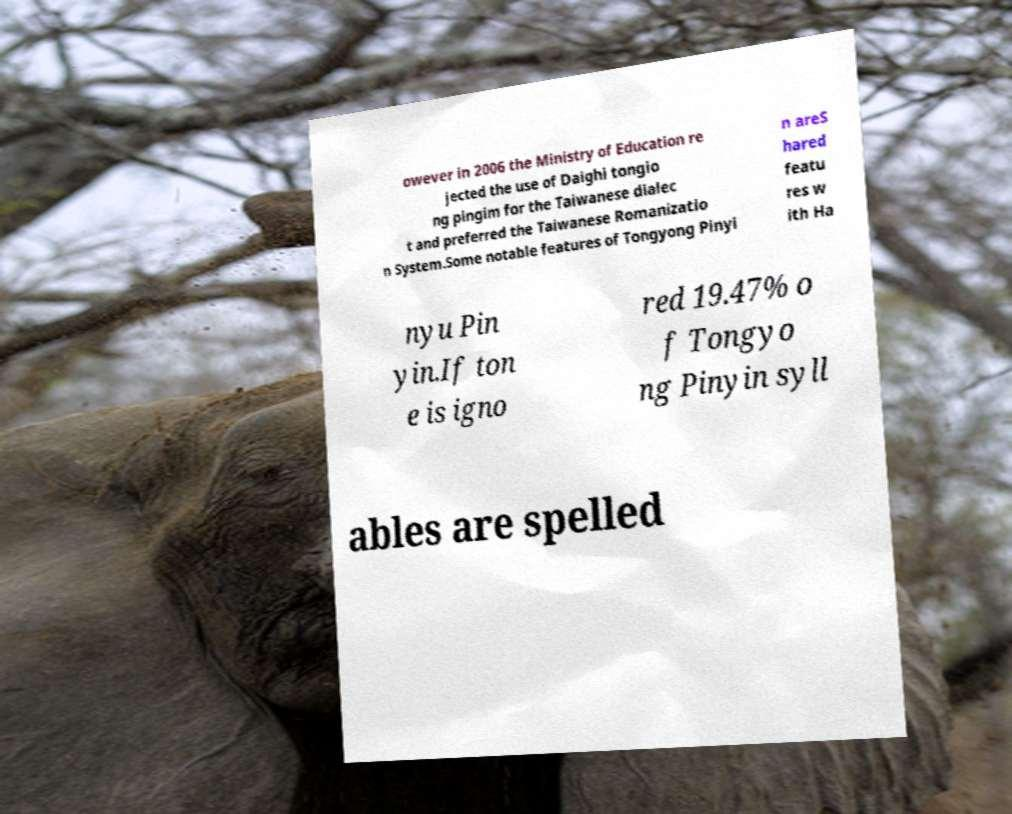There's text embedded in this image that I need extracted. Can you transcribe it verbatim? owever in 2006 the Ministry of Education re jected the use of Daighi tongio ng pingim for the Taiwanese dialec t and preferred the Taiwanese Romanizatio n System.Some notable features of Tongyong Pinyi n areS hared featu res w ith Ha nyu Pin yin.If ton e is igno red 19.47% o f Tongyo ng Pinyin syll ables are spelled 